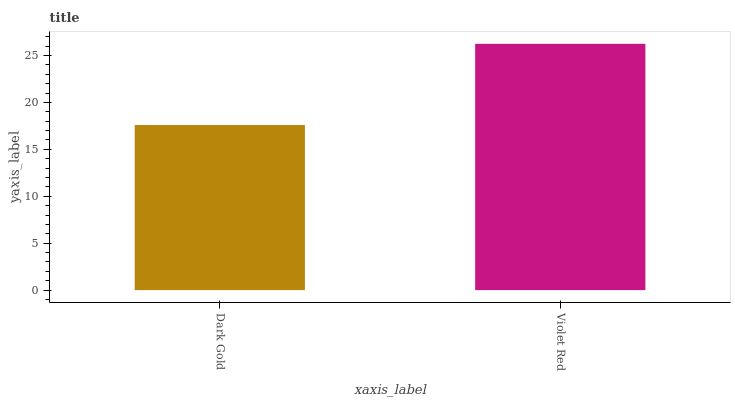Is Dark Gold the minimum?
Answer yes or no. Yes. Is Violet Red the maximum?
Answer yes or no. Yes. Is Violet Red the minimum?
Answer yes or no. No. Is Violet Red greater than Dark Gold?
Answer yes or no. Yes. Is Dark Gold less than Violet Red?
Answer yes or no. Yes. Is Dark Gold greater than Violet Red?
Answer yes or no. No. Is Violet Red less than Dark Gold?
Answer yes or no. No. Is Violet Red the high median?
Answer yes or no. Yes. Is Dark Gold the low median?
Answer yes or no. Yes. Is Dark Gold the high median?
Answer yes or no. No. Is Violet Red the low median?
Answer yes or no. No. 